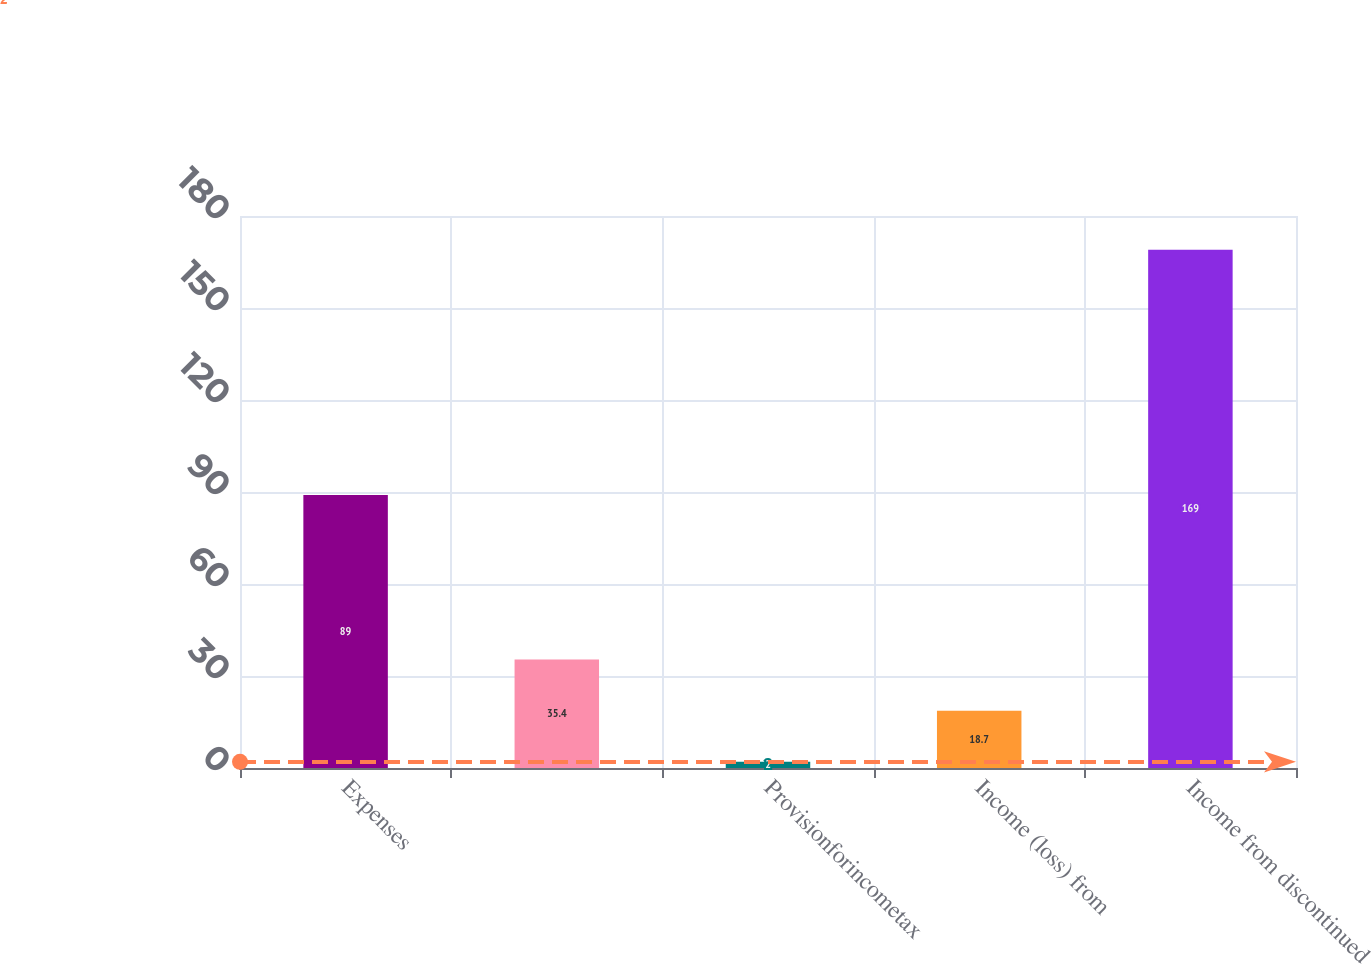Convert chart. <chart><loc_0><loc_0><loc_500><loc_500><bar_chart><fcel>Expenses<fcel>Unnamed: 1<fcel>Provisionforincometax<fcel>Income (loss) from<fcel>Income from discontinued<nl><fcel>89<fcel>35.4<fcel>2<fcel>18.7<fcel>169<nl></chart> 